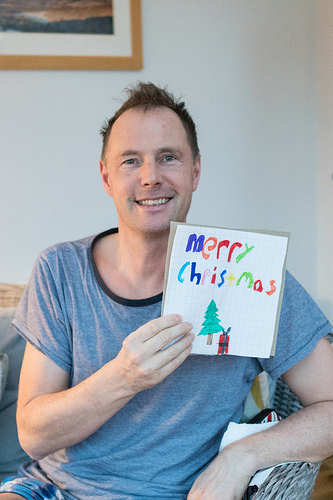<image>
Is the paper in the man? No. The paper is not contained within the man. These objects have a different spatial relationship. Where is the man in relation to the card? Is it next to the card? Yes. The man is positioned adjacent to the card, located nearby in the same general area. Is the man next to the paper? No. The man is not positioned next to the paper. They are located in different areas of the scene. 